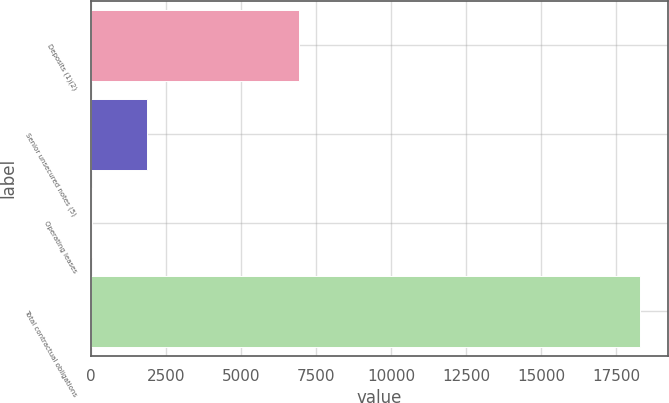<chart> <loc_0><loc_0><loc_500><loc_500><bar_chart><fcel>Deposits (1)(2)<fcel>Senior unsecured notes (5)<fcel>Operating leases<fcel>Total contractual obligations<nl><fcel>6946<fcel>1884.6<fcel>62<fcel>18288<nl></chart> 